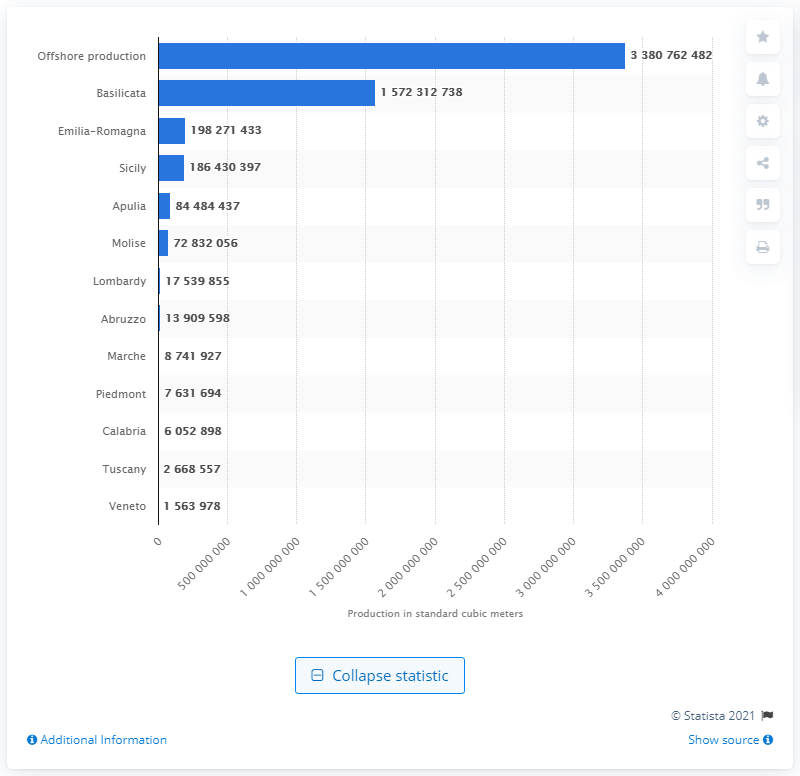Indicate a few pertinent items in this graphic. In 2018, Emilia-Romagna was the region with the highest production of natural gas. In the year 2018, the region of Emilia-Romagna produced a total of 198,271,433 cubic meters of natural gas. Basilicata was the region with the highest natural gas production in 2018. 